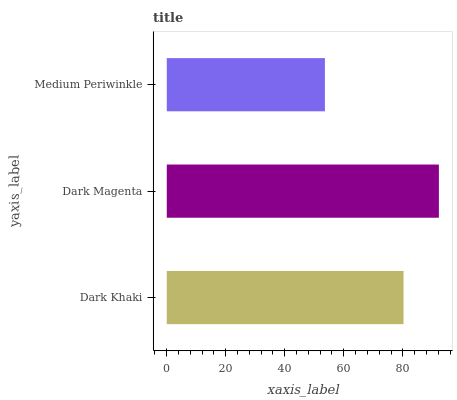Is Medium Periwinkle the minimum?
Answer yes or no. Yes. Is Dark Magenta the maximum?
Answer yes or no. Yes. Is Dark Magenta the minimum?
Answer yes or no. No. Is Medium Periwinkle the maximum?
Answer yes or no. No. Is Dark Magenta greater than Medium Periwinkle?
Answer yes or no. Yes. Is Medium Periwinkle less than Dark Magenta?
Answer yes or no. Yes. Is Medium Periwinkle greater than Dark Magenta?
Answer yes or no. No. Is Dark Magenta less than Medium Periwinkle?
Answer yes or no. No. Is Dark Khaki the high median?
Answer yes or no. Yes. Is Dark Khaki the low median?
Answer yes or no. Yes. Is Dark Magenta the high median?
Answer yes or no. No. Is Dark Magenta the low median?
Answer yes or no. No. 